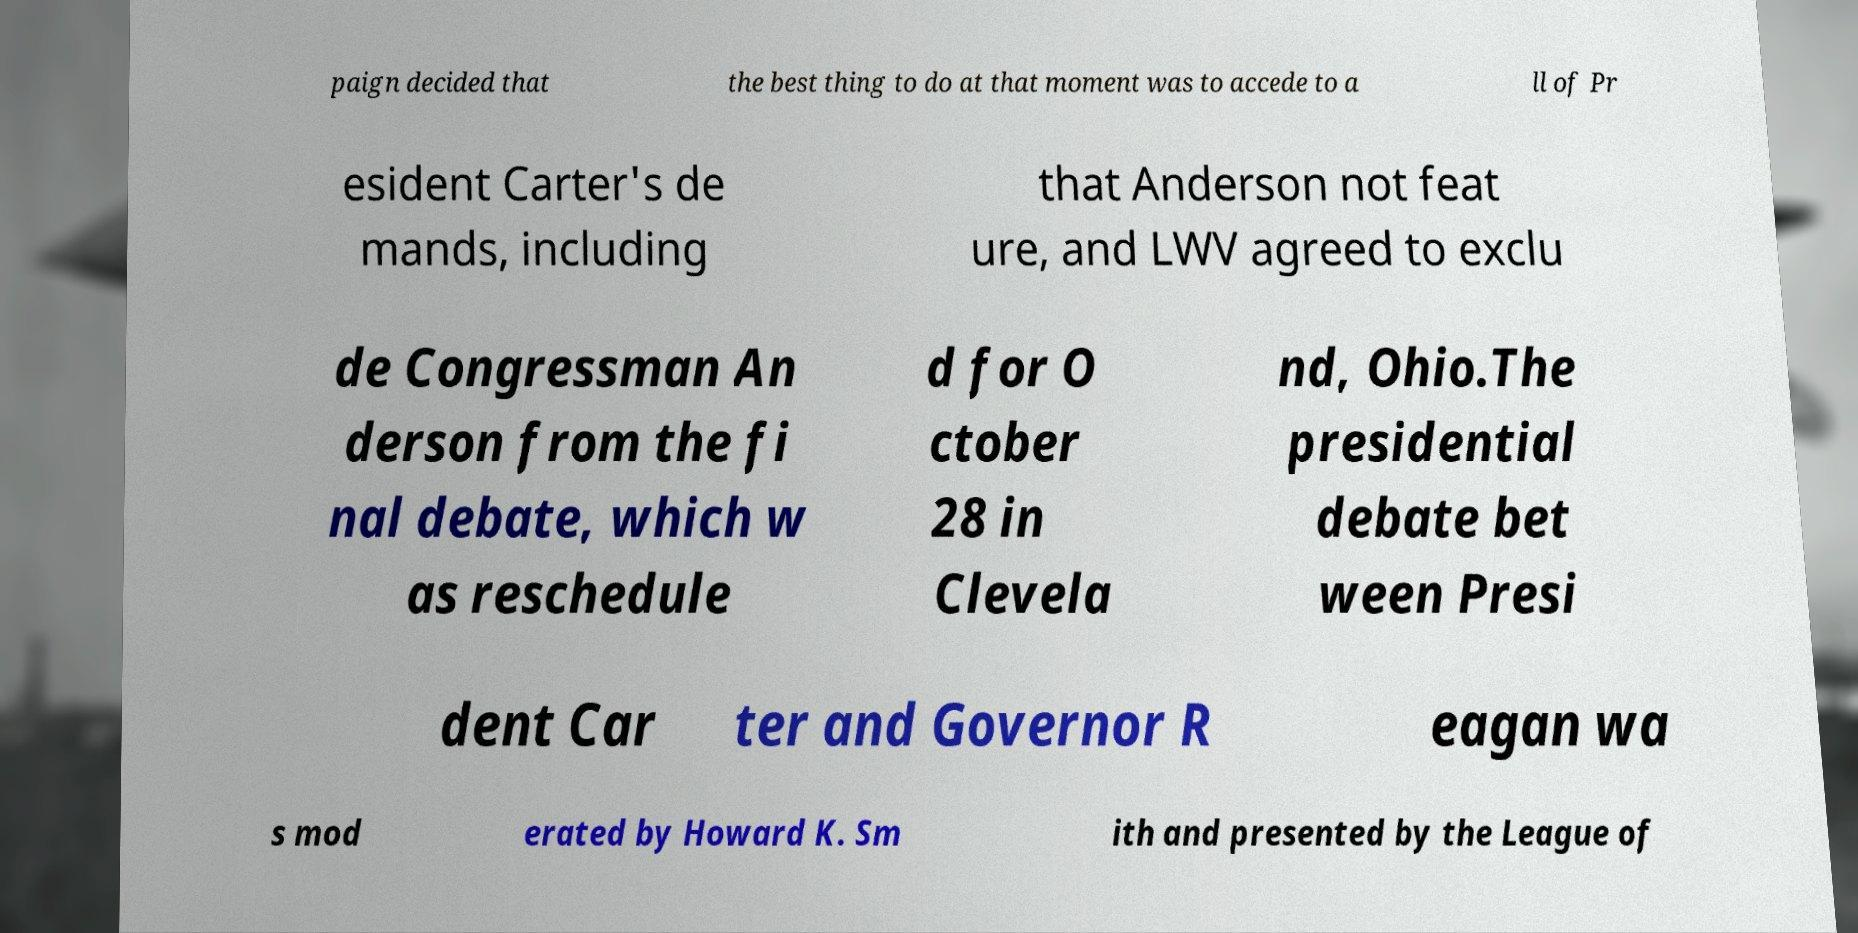Can you accurately transcribe the text from the provided image for me? paign decided that the best thing to do at that moment was to accede to a ll of Pr esident Carter's de mands, including that Anderson not feat ure, and LWV agreed to exclu de Congressman An derson from the fi nal debate, which w as reschedule d for O ctober 28 in Clevela nd, Ohio.The presidential debate bet ween Presi dent Car ter and Governor R eagan wa s mod erated by Howard K. Sm ith and presented by the League of 